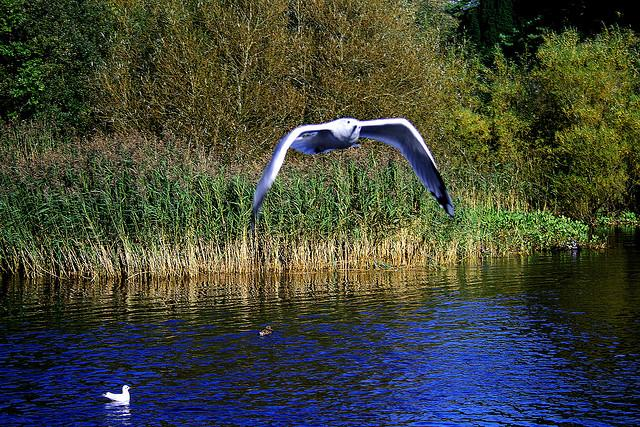The bird on the water has what type feet? Please explain your reasoning. webbed. The bird on the water is a duck and has feet that are webbed for swimming. 